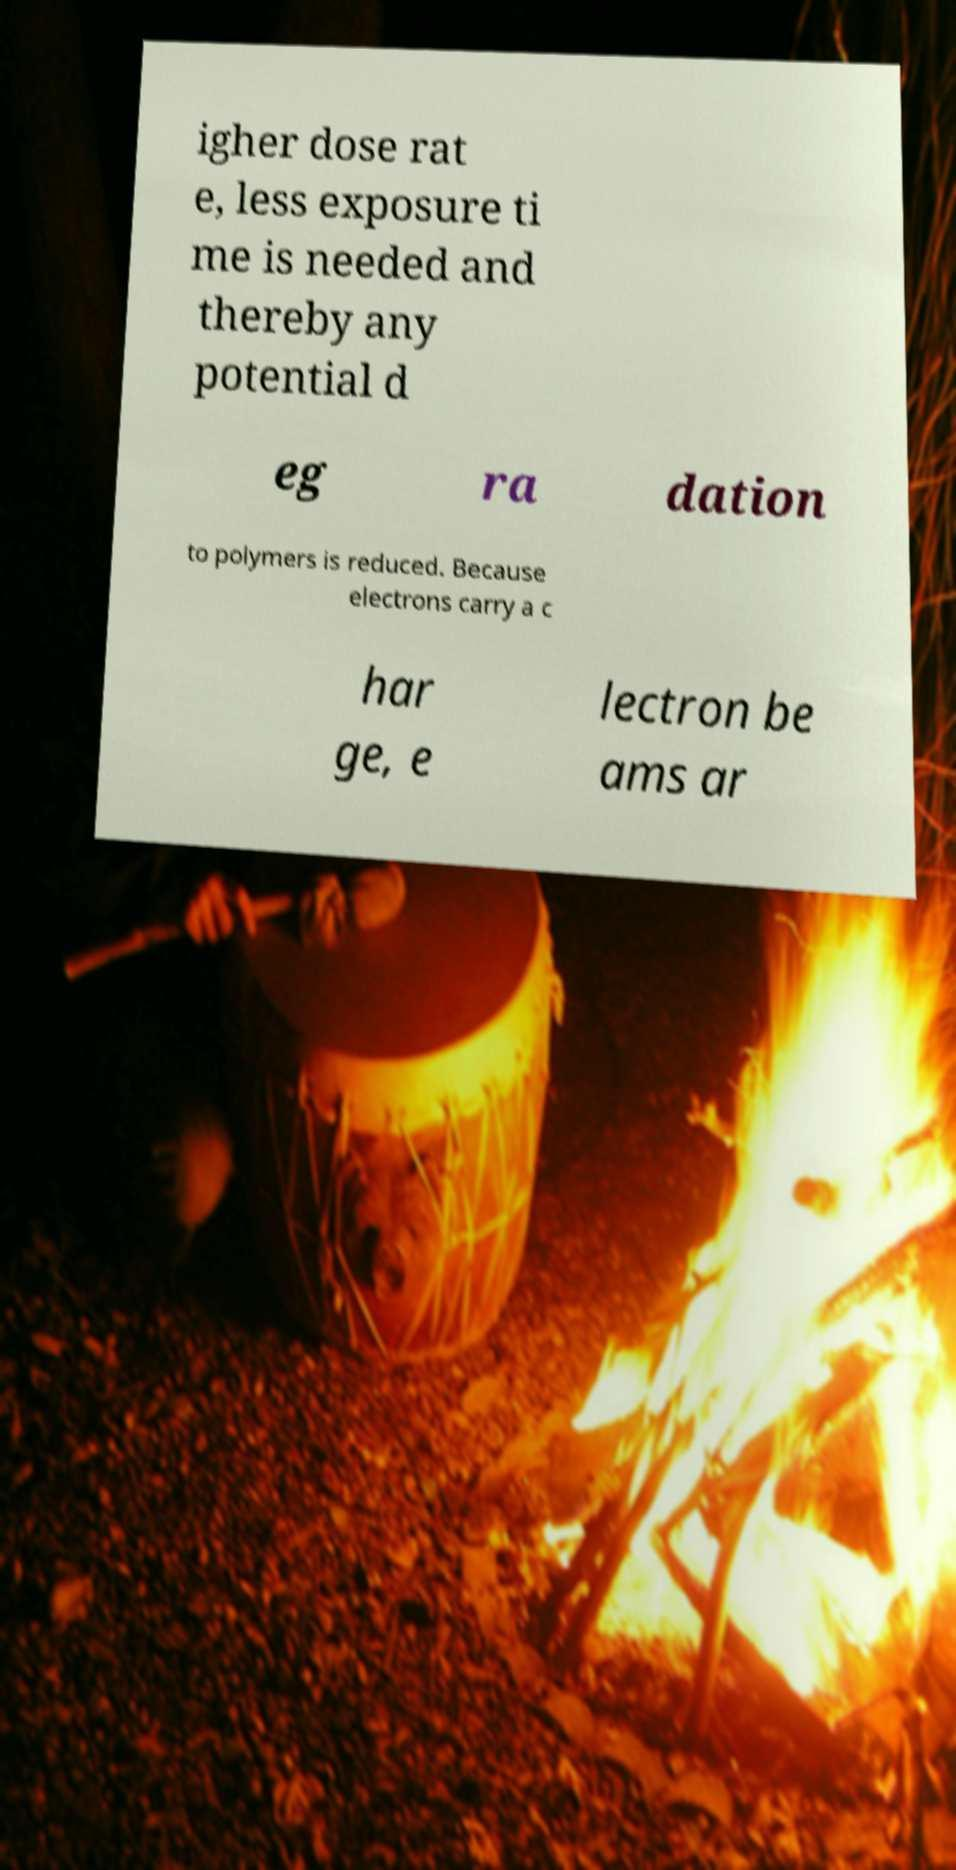I need the written content from this picture converted into text. Can you do that? igher dose rat e, less exposure ti me is needed and thereby any potential d eg ra dation to polymers is reduced. Because electrons carry a c har ge, e lectron be ams ar 